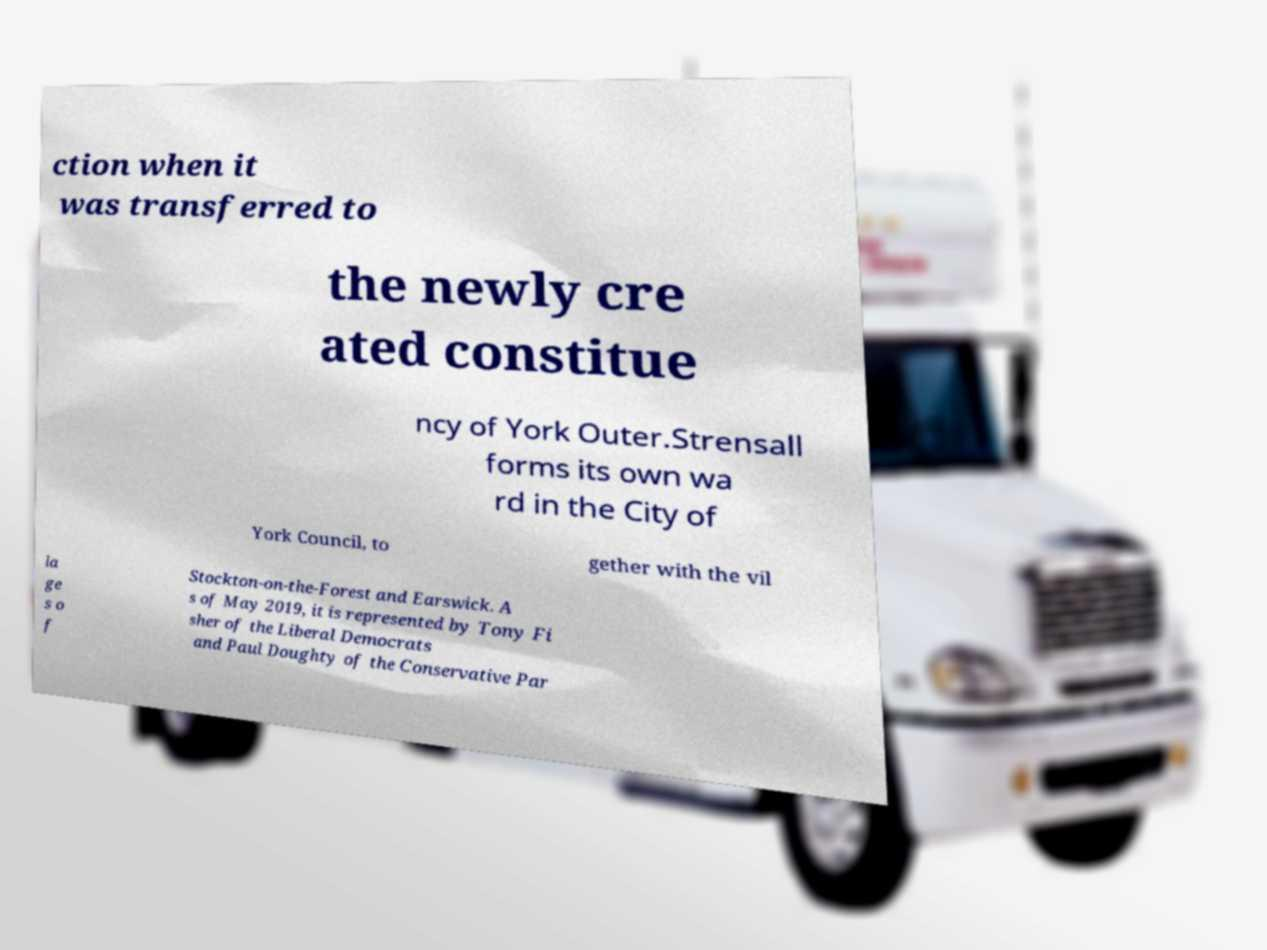What messages or text are displayed in this image? I need them in a readable, typed format. ction when it was transferred to the newly cre ated constitue ncy of York Outer.Strensall forms its own wa rd in the City of York Council, to gether with the vil la ge s o f Stockton-on-the-Forest and Earswick. A s of May 2019, it is represented by Tony Fi sher of the Liberal Democrats and Paul Doughty of the Conservative Par 